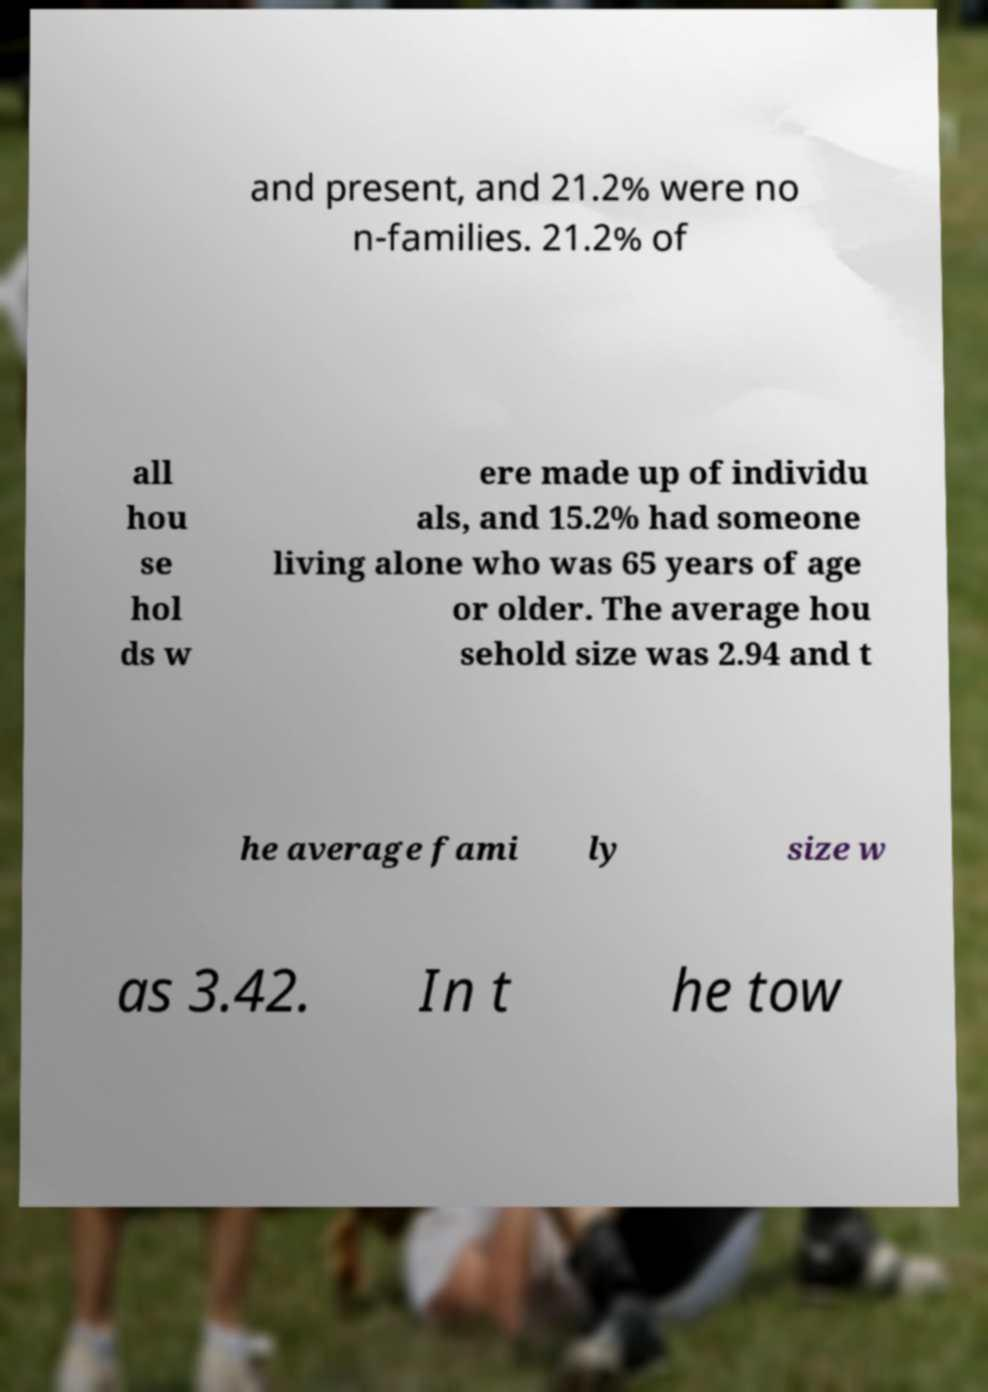Can you read and provide the text displayed in the image?This photo seems to have some interesting text. Can you extract and type it out for me? and present, and 21.2% were no n-families. 21.2% of all hou se hol ds w ere made up of individu als, and 15.2% had someone living alone who was 65 years of age or older. The average hou sehold size was 2.94 and t he average fami ly size w as 3.42. In t he tow 